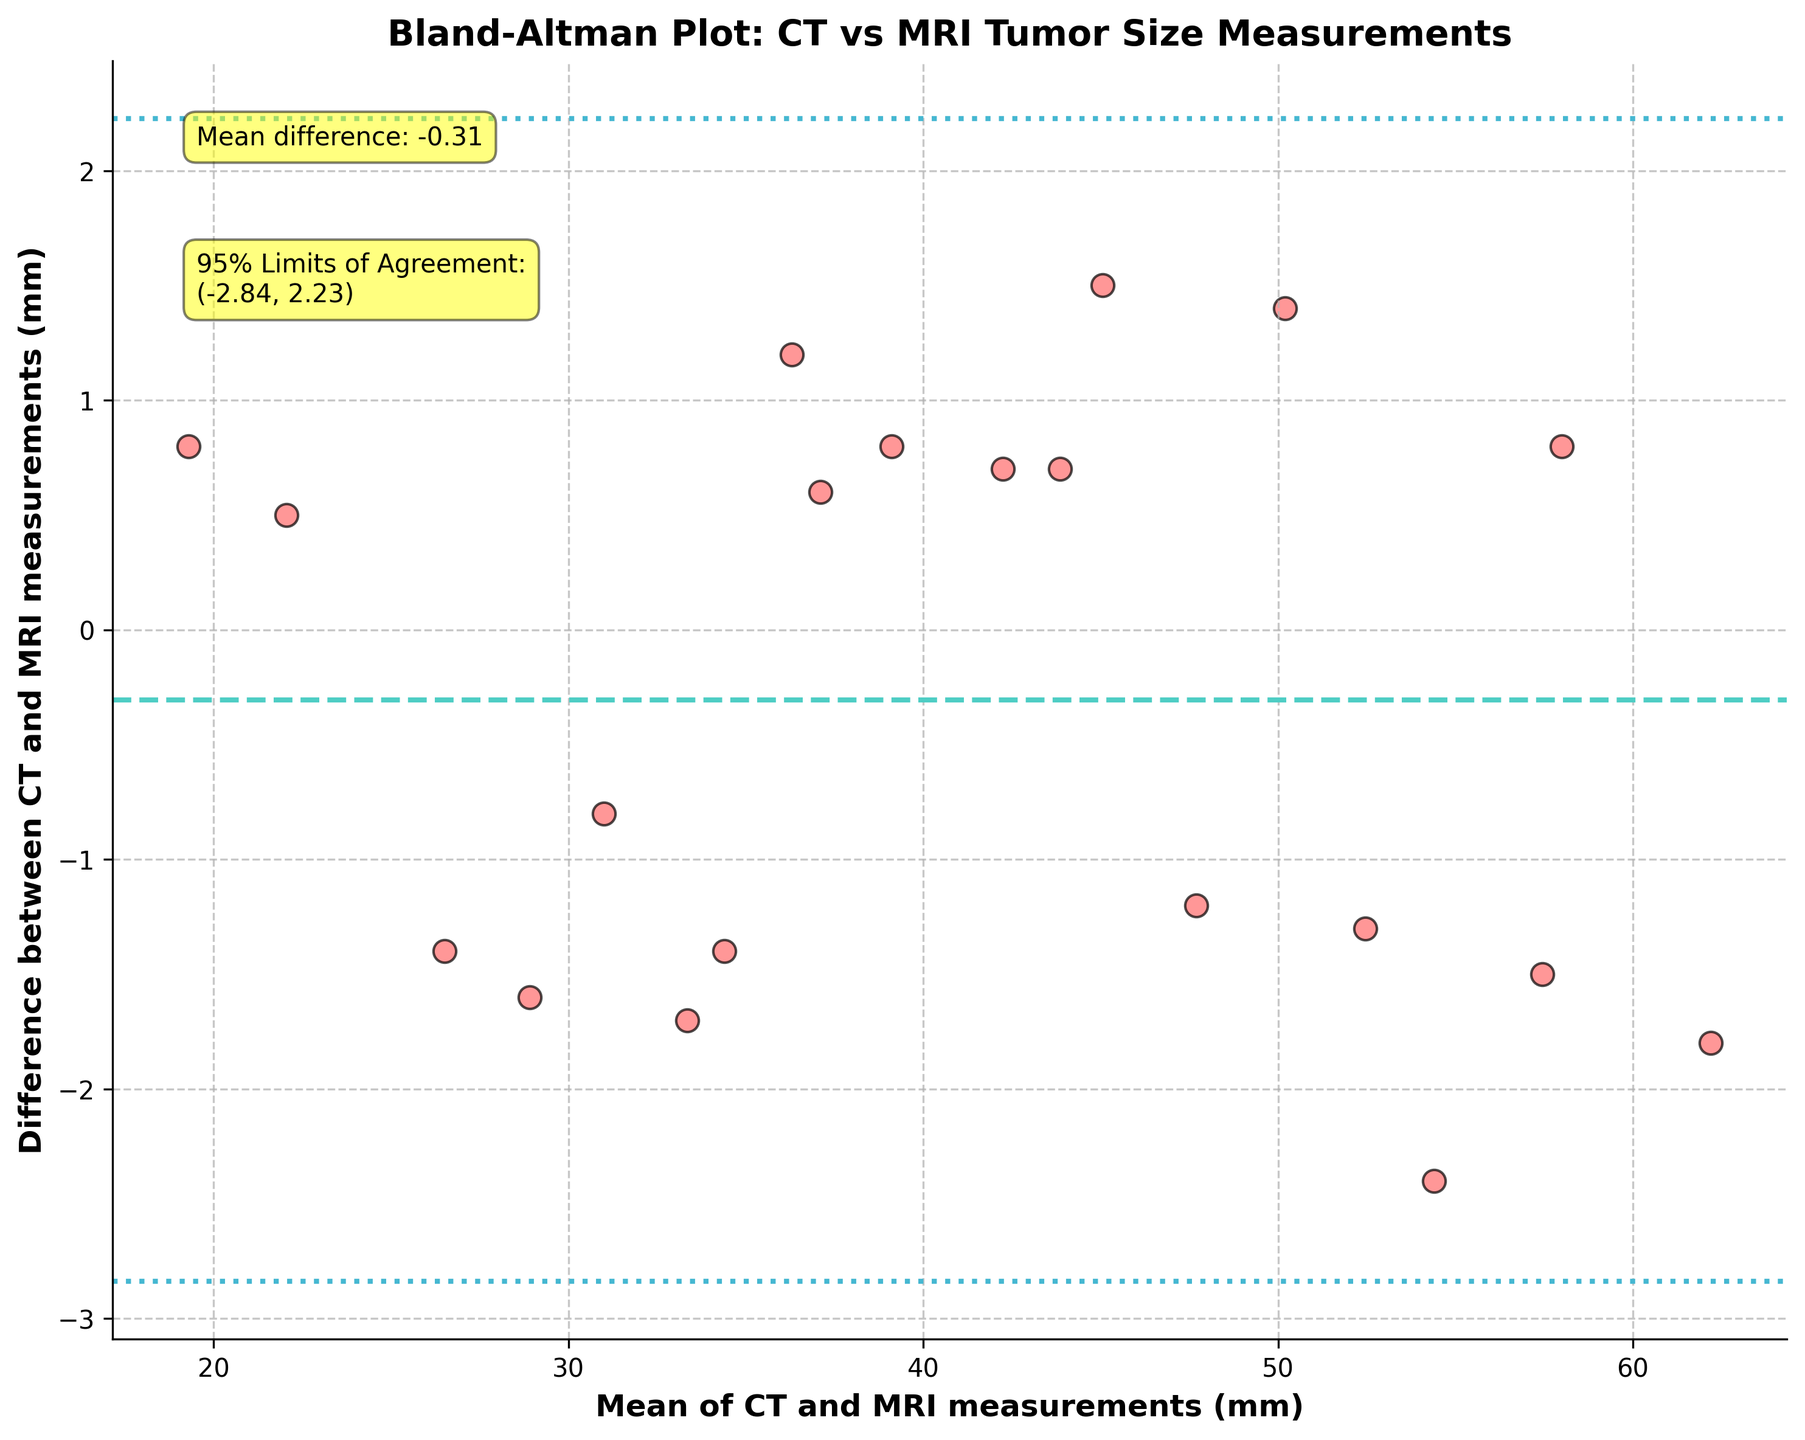How many data points are displayed in the plot? Count the number of individual scatter points shown in the Bland-Altman plot. There should be one point for each pair of CT and MRI measurements.
Answer: 20 What's the title of the plot? The title is typically found at the top of the plot and summarizes what the visual represents. In this case, look for it above the graphical area.
Answer: Bland-Altman Plot: CT vs MRI Tumor Size Measurements What is the mean difference between CT and MRI measurements? Check for a horizontal line labeled "Mean difference" and its corresponding annotation on the plot. The value is given within the text box.
Answer: 0.79 What are the 95% limits of agreement? The limits are represented by two horizontal dashed lines, often annotated directly on the plot. Look for annotations that read "95% Limits of Agreement" along with their values.
Answer: (-1.94, 3.53) What does a data point below the lower limit of agreement signify? Understand that the lower limit of agreement represents the extreme lower range of acceptable agreement between the two measurement methods. Points below this indicate significant disagreement.
Answer: Significant disagreement, MRI > CT Do more data points fall above or below the mean difference line? Visually count the number of points above and below the line representing the mean difference to determine their distribution.
Answer: Above What does the mean of the CT and MRI measurements represent on the x-axis? The x-axis represents the average tumor size measured by both CT and MRI for each data pair. Thus, each point's x-coordinate is the average of one pair of measurements.
Answer: Mean of CT and MRI measurements Is there a general trend with the differences as the mean CT and MRI measurements increase? Examine the scatter plot to see if the spread of differences increases or decreases as the average measurements (x-axis) increase.
Answer: No clear trend What is the difference between CT and MRI measurements for a Mean of 37 mm? Locate the data point corresponding to a mean of approximately 37 mm on the x-axis, then note the difference on the y-axis for that point.
Answer: About 0.6 mm What might be a concern if many points fall outside the 95% limits of agreement? If numerous points lie outside these limits, it indicates poor agreement between the two measurement methods, suggesting they may not be interchangeable.
Answer: Poor agreement, not interchangeable 